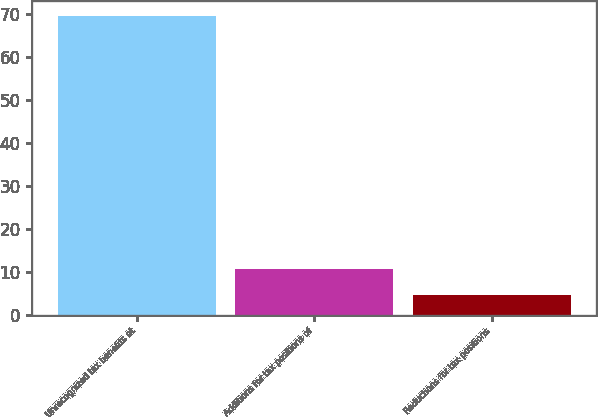Convert chart to OTSL. <chart><loc_0><loc_0><loc_500><loc_500><bar_chart><fcel>Unrecognized tax benefits at<fcel>Additions for tax positions of<fcel>Reductions for tax positions<nl><fcel>69.51<fcel>10.71<fcel>4.7<nl></chart> 